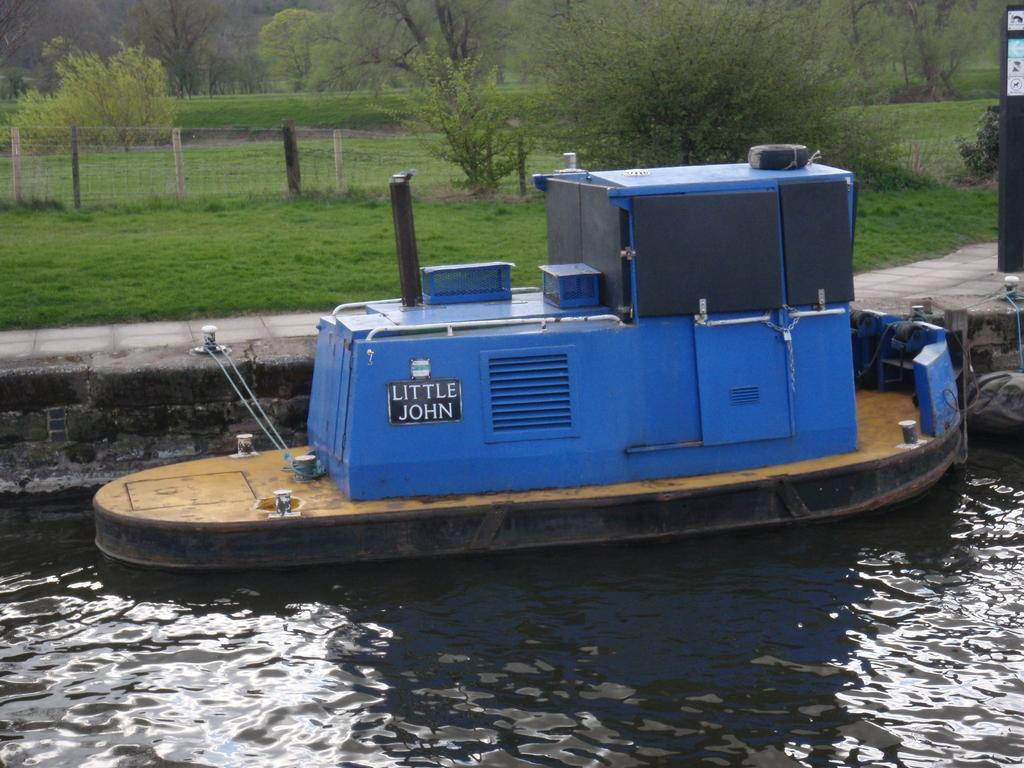What type of vehicle is in the water in the foreground? There is a wooden barge vehicle in the water in the foreground. What can be seen in the background of the image? There is green grass, a metal fence, and trees in the background. Where can you purchase a ticket for the thrilling ride on the wooden barge vehicle? There is no mention of a ride or a ticket in the image, as it only features a wooden barge vehicle in the water and a background with green grass, a metal fence, and trees. 